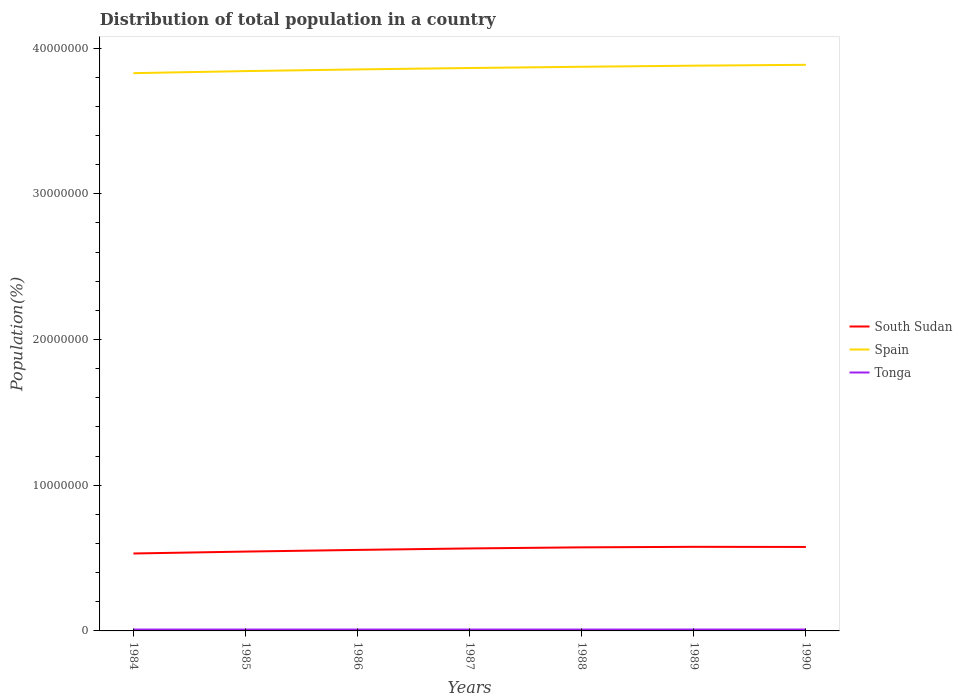Across all years, what is the maximum population of in Spain?
Your response must be concise. 3.83e+07. What is the total population of in South Sudan in the graph?
Offer a very short reply. -2.90e+05. What is the difference between the highest and the second highest population of in Spain?
Ensure brevity in your answer.  5.72e+05. How many lines are there?
Your response must be concise. 3. How many years are there in the graph?
Offer a very short reply. 7. Are the values on the major ticks of Y-axis written in scientific E-notation?
Offer a very short reply. No. How are the legend labels stacked?
Your answer should be very brief. Vertical. What is the title of the graph?
Give a very brief answer. Distribution of total population in a country. Does "Fiji" appear as one of the legend labels in the graph?
Provide a short and direct response. No. What is the label or title of the Y-axis?
Your response must be concise. Population(%). What is the Population(%) of South Sudan in 1984?
Your answer should be very brief. 5.31e+06. What is the Population(%) in Spain in 1984?
Provide a short and direct response. 3.83e+07. What is the Population(%) in Tonga in 1984?
Make the answer very short. 9.38e+04. What is the Population(%) in South Sudan in 1985?
Ensure brevity in your answer.  5.44e+06. What is the Population(%) of Spain in 1985?
Provide a succinct answer. 3.84e+07. What is the Population(%) in Tonga in 1985?
Provide a succinct answer. 9.40e+04. What is the Population(%) in South Sudan in 1986?
Provide a succinct answer. 5.56e+06. What is the Population(%) of Spain in 1986?
Ensure brevity in your answer.  3.85e+07. What is the Population(%) in Tonga in 1986?
Your answer should be compact. 9.41e+04. What is the Population(%) of South Sudan in 1987?
Offer a terse response. 5.66e+06. What is the Population(%) of Spain in 1987?
Your answer should be compact. 3.86e+07. What is the Population(%) of Tonga in 1987?
Offer a very short reply. 9.44e+04. What is the Population(%) of South Sudan in 1988?
Offer a very short reply. 5.74e+06. What is the Population(%) in Spain in 1988?
Your answer should be compact. 3.87e+07. What is the Population(%) in Tonga in 1988?
Make the answer very short. 9.47e+04. What is the Population(%) in South Sudan in 1989?
Offer a very short reply. 5.77e+06. What is the Population(%) of Spain in 1989?
Offer a very short reply. 3.88e+07. What is the Population(%) of Tonga in 1989?
Your response must be concise. 9.49e+04. What is the Population(%) in South Sudan in 1990?
Your response must be concise. 5.76e+06. What is the Population(%) in Spain in 1990?
Make the answer very short. 3.89e+07. What is the Population(%) in Tonga in 1990?
Ensure brevity in your answer.  9.52e+04. Across all years, what is the maximum Population(%) in South Sudan?
Ensure brevity in your answer.  5.77e+06. Across all years, what is the maximum Population(%) of Spain?
Offer a terse response. 3.89e+07. Across all years, what is the maximum Population(%) of Tonga?
Provide a short and direct response. 9.52e+04. Across all years, what is the minimum Population(%) in South Sudan?
Offer a very short reply. 5.31e+06. Across all years, what is the minimum Population(%) of Spain?
Keep it short and to the point. 3.83e+07. Across all years, what is the minimum Population(%) in Tonga?
Provide a succinct answer. 9.38e+04. What is the total Population(%) of South Sudan in the graph?
Offer a very short reply. 3.92e+07. What is the total Population(%) of Spain in the graph?
Provide a short and direct response. 2.70e+08. What is the total Population(%) in Tonga in the graph?
Offer a very short reply. 6.61e+05. What is the difference between the Population(%) in South Sudan in 1984 and that in 1985?
Your answer should be very brief. -1.31e+05. What is the difference between the Population(%) in Spain in 1984 and that in 1985?
Give a very brief answer. -1.40e+05. What is the difference between the Population(%) in Tonga in 1984 and that in 1985?
Your answer should be compact. -115. What is the difference between the Population(%) of South Sudan in 1984 and that in 1986?
Offer a very short reply. -2.45e+05. What is the difference between the Population(%) of Spain in 1984 and that in 1986?
Keep it short and to the point. -2.57e+05. What is the difference between the Population(%) of Tonga in 1984 and that in 1986?
Your answer should be very brief. -309. What is the difference between the Population(%) of South Sudan in 1984 and that in 1987?
Keep it short and to the point. -3.46e+05. What is the difference between the Population(%) of Spain in 1984 and that in 1987?
Offer a very short reply. -3.52e+05. What is the difference between the Population(%) of Tonga in 1984 and that in 1987?
Provide a short and direct response. -561. What is the difference between the Population(%) of South Sudan in 1984 and that in 1988?
Keep it short and to the point. -4.21e+05. What is the difference between the Population(%) in Spain in 1984 and that in 1988?
Provide a short and direct response. -4.37e+05. What is the difference between the Population(%) of Tonga in 1984 and that in 1988?
Your answer should be very brief. -842. What is the difference between the Population(%) of South Sudan in 1984 and that in 1989?
Provide a short and direct response. -4.57e+05. What is the difference between the Population(%) in Spain in 1984 and that in 1989?
Provide a short and direct response. -5.13e+05. What is the difference between the Population(%) in Tonga in 1984 and that in 1989?
Give a very brief answer. -1105. What is the difference between the Population(%) of South Sudan in 1984 and that in 1990?
Make the answer very short. -4.48e+05. What is the difference between the Population(%) in Spain in 1984 and that in 1990?
Your answer should be very brief. -5.72e+05. What is the difference between the Population(%) of Tonga in 1984 and that in 1990?
Offer a very short reply. -1314. What is the difference between the Population(%) of South Sudan in 1985 and that in 1986?
Keep it short and to the point. -1.15e+05. What is the difference between the Population(%) of Spain in 1985 and that in 1986?
Keep it short and to the point. -1.17e+05. What is the difference between the Population(%) of Tonga in 1985 and that in 1986?
Your answer should be compact. -194. What is the difference between the Population(%) in South Sudan in 1985 and that in 1987?
Your answer should be compact. -2.15e+05. What is the difference between the Population(%) in Spain in 1985 and that in 1987?
Ensure brevity in your answer.  -2.12e+05. What is the difference between the Population(%) in Tonga in 1985 and that in 1987?
Ensure brevity in your answer.  -446. What is the difference between the Population(%) in South Sudan in 1985 and that in 1988?
Keep it short and to the point. -2.90e+05. What is the difference between the Population(%) of Spain in 1985 and that in 1988?
Offer a very short reply. -2.97e+05. What is the difference between the Population(%) in Tonga in 1985 and that in 1988?
Your answer should be very brief. -727. What is the difference between the Population(%) of South Sudan in 1985 and that in 1989?
Keep it short and to the point. -3.26e+05. What is the difference between the Population(%) in Spain in 1985 and that in 1989?
Give a very brief answer. -3.73e+05. What is the difference between the Population(%) of Tonga in 1985 and that in 1989?
Offer a terse response. -990. What is the difference between the Population(%) of South Sudan in 1985 and that in 1990?
Your answer should be compact. -3.17e+05. What is the difference between the Population(%) in Spain in 1985 and that in 1990?
Provide a succinct answer. -4.32e+05. What is the difference between the Population(%) of Tonga in 1985 and that in 1990?
Keep it short and to the point. -1199. What is the difference between the Population(%) of South Sudan in 1986 and that in 1987?
Keep it short and to the point. -1.00e+05. What is the difference between the Population(%) in Spain in 1986 and that in 1987?
Provide a short and direct response. -9.52e+04. What is the difference between the Population(%) of Tonga in 1986 and that in 1987?
Provide a succinct answer. -252. What is the difference between the Population(%) of South Sudan in 1986 and that in 1988?
Your answer should be compact. -1.75e+05. What is the difference between the Population(%) of Spain in 1986 and that in 1988?
Offer a very short reply. -1.80e+05. What is the difference between the Population(%) in Tonga in 1986 and that in 1988?
Your answer should be very brief. -533. What is the difference between the Population(%) in South Sudan in 1986 and that in 1989?
Offer a terse response. -2.12e+05. What is the difference between the Population(%) in Spain in 1986 and that in 1989?
Make the answer very short. -2.56e+05. What is the difference between the Population(%) of Tonga in 1986 and that in 1989?
Your answer should be compact. -796. What is the difference between the Population(%) in South Sudan in 1986 and that in 1990?
Provide a short and direct response. -2.02e+05. What is the difference between the Population(%) of Spain in 1986 and that in 1990?
Make the answer very short. -3.15e+05. What is the difference between the Population(%) in Tonga in 1986 and that in 1990?
Your response must be concise. -1005. What is the difference between the Population(%) of South Sudan in 1987 and that in 1988?
Provide a short and direct response. -7.50e+04. What is the difference between the Population(%) of Spain in 1987 and that in 1988?
Your answer should be very brief. -8.50e+04. What is the difference between the Population(%) of Tonga in 1987 and that in 1988?
Provide a short and direct response. -281. What is the difference between the Population(%) in South Sudan in 1987 and that in 1989?
Offer a very short reply. -1.11e+05. What is the difference between the Population(%) in Spain in 1987 and that in 1989?
Ensure brevity in your answer.  -1.61e+05. What is the difference between the Population(%) of Tonga in 1987 and that in 1989?
Offer a terse response. -544. What is the difference between the Population(%) in South Sudan in 1987 and that in 1990?
Keep it short and to the point. -1.02e+05. What is the difference between the Population(%) of Spain in 1987 and that in 1990?
Provide a short and direct response. -2.20e+05. What is the difference between the Population(%) of Tonga in 1987 and that in 1990?
Ensure brevity in your answer.  -753. What is the difference between the Population(%) of South Sudan in 1988 and that in 1989?
Provide a short and direct response. -3.61e+04. What is the difference between the Population(%) in Spain in 1988 and that in 1989?
Offer a terse response. -7.56e+04. What is the difference between the Population(%) in Tonga in 1988 and that in 1989?
Offer a terse response. -263. What is the difference between the Population(%) in South Sudan in 1988 and that in 1990?
Your response must be concise. -2.70e+04. What is the difference between the Population(%) of Spain in 1988 and that in 1990?
Your answer should be compact. -1.35e+05. What is the difference between the Population(%) in Tonga in 1988 and that in 1990?
Provide a short and direct response. -472. What is the difference between the Population(%) of South Sudan in 1989 and that in 1990?
Offer a terse response. 9115. What is the difference between the Population(%) of Spain in 1989 and that in 1990?
Make the answer very short. -5.90e+04. What is the difference between the Population(%) in Tonga in 1989 and that in 1990?
Your answer should be very brief. -209. What is the difference between the Population(%) of South Sudan in 1984 and the Population(%) of Spain in 1985?
Provide a succinct answer. -3.31e+07. What is the difference between the Population(%) in South Sudan in 1984 and the Population(%) in Tonga in 1985?
Your answer should be very brief. 5.22e+06. What is the difference between the Population(%) in Spain in 1984 and the Population(%) in Tonga in 1985?
Provide a succinct answer. 3.82e+07. What is the difference between the Population(%) of South Sudan in 1984 and the Population(%) of Spain in 1986?
Your response must be concise. -3.32e+07. What is the difference between the Population(%) of South Sudan in 1984 and the Population(%) of Tonga in 1986?
Provide a short and direct response. 5.22e+06. What is the difference between the Population(%) of Spain in 1984 and the Population(%) of Tonga in 1986?
Provide a succinct answer. 3.82e+07. What is the difference between the Population(%) in South Sudan in 1984 and the Population(%) in Spain in 1987?
Your answer should be very brief. -3.33e+07. What is the difference between the Population(%) of South Sudan in 1984 and the Population(%) of Tonga in 1987?
Provide a short and direct response. 5.22e+06. What is the difference between the Population(%) in Spain in 1984 and the Population(%) in Tonga in 1987?
Your answer should be very brief. 3.82e+07. What is the difference between the Population(%) in South Sudan in 1984 and the Population(%) in Spain in 1988?
Give a very brief answer. -3.34e+07. What is the difference between the Population(%) of South Sudan in 1984 and the Population(%) of Tonga in 1988?
Your answer should be compact. 5.22e+06. What is the difference between the Population(%) of Spain in 1984 and the Population(%) of Tonga in 1988?
Give a very brief answer. 3.82e+07. What is the difference between the Population(%) in South Sudan in 1984 and the Population(%) in Spain in 1989?
Offer a very short reply. -3.35e+07. What is the difference between the Population(%) of South Sudan in 1984 and the Population(%) of Tonga in 1989?
Keep it short and to the point. 5.22e+06. What is the difference between the Population(%) of Spain in 1984 and the Population(%) of Tonga in 1989?
Give a very brief answer. 3.82e+07. What is the difference between the Population(%) of South Sudan in 1984 and the Population(%) of Spain in 1990?
Your answer should be very brief. -3.35e+07. What is the difference between the Population(%) of South Sudan in 1984 and the Population(%) of Tonga in 1990?
Your response must be concise. 5.22e+06. What is the difference between the Population(%) of Spain in 1984 and the Population(%) of Tonga in 1990?
Your response must be concise. 3.82e+07. What is the difference between the Population(%) of South Sudan in 1985 and the Population(%) of Spain in 1986?
Make the answer very short. -3.31e+07. What is the difference between the Population(%) of South Sudan in 1985 and the Population(%) of Tonga in 1986?
Your answer should be very brief. 5.35e+06. What is the difference between the Population(%) in Spain in 1985 and the Population(%) in Tonga in 1986?
Ensure brevity in your answer.  3.83e+07. What is the difference between the Population(%) of South Sudan in 1985 and the Population(%) of Spain in 1987?
Make the answer very short. -3.32e+07. What is the difference between the Population(%) of South Sudan in 1985 and the Population(%) of Tonga in 1987?
Offer a very short reply. 5.35e+06. What is the difference between the Population(%) of Spain in 1985 and the Population(%) of Tonga in 1987?
Ensure brevity in your answer.  3.83e+07. What is the difference between the Population(%) of South Sudan in 1985 and the Population(%) of Spain in 1988?
Offer a terse response. -3.33e+07. What is the difference between the Population(%) in South Sudan in 1985 and the Population(%) in Tonga in 1988?
Keep it short and to the point. 5.35e+06. What is the difference between the Population(%) of Spain in 1985 and the Population(%) of Tonga in 1988?
Your response must be concise. 3.83e+07. What is the difference between the Population(%) of South Sudan in 1985 and the Population(%) of Spain in 1989?
Ensure brevity in your answer.  -3.33e+07. What is the difference between the Population(%) in South Sudan in 1985 and the Population(%) in Tonga in 1989?
Your answer should be very brief. 5.35e+06. What is the difference between the Population(%) in Spain in 1985 and the Population(%) in Tonga in 1989?
Give a very brief answer. 3.83e+07. What is the difference between the Population(%) of South Sudan in 1985 and the Population(%) of Spain in 1990?
Offer a terse response. -3.34e+07. What is the difference between the Population(%) in South Sudan in 1985 and the Population(%) in Tonga in 1990?
Offer a terse response. 5.35e+06. What is the difference between the Population(%) of Spain in 1985 and the Population(%) of Tonga in 1990?
Give a very brief answer. 3.83e+07. What is the difference between the Population(%) of South Sudan in 1986 and the Population(%) of Spain in 1987?
Provide a succinct answer. -3.31e+07. What is the difference between the Population(%) in South Sudan in 1986 and the Population(%) in Tonga in 1987?
Provide a short and direct response. 5.47e+06. What is the difference between the Population(%) of Spain in 1986 and the Population(%) of Tonga in 1987?
Ensure brevity in your answer.  3.84e+07. What is the difference between the Population(%) of South Sudan in 1986 and the Population(%) of Spain in 1988?
Your answer should be compact. -3.32e+07. What is the difference between the Population(%) of South Sudan in 1986 and the Population(%) of Tonga in 1988?
Give a very brief answer. 5.47e+06. What is the difference between the Population(%) of Spain in 1986 and the Population(%) of Tonga in 1988?
Give a very brief answer. 3.84e+07. What is the difference between the Population(%) in South Sudan in 1986 and the Population(%) in Spain in 1989?
Your response must be concise. -3.32e+07. What is the difference between the Population(%) of South Sudan in 1986 and the Population(%) of Tonga in 1989?
Give a very brief answer. 5.46e+06. What is the difference between the Population(%) in Spain in 1986 and the Population(%) in Tonga in 1989?
Offer a terse response. 3.84e+07. What is the difference between the Population(%) in South Sudan in 1986 and the Population(%) in Spain in 1990?
Offer a terse response. -3.33e+07. What is the difference between the Population(%) in South Sudan in 1986 and the Population(%) in Tonga in 1990?
Your answer should be very brief. 5.46e+06. What is the difference between the Population(%) in Spain in 1986 and the Population(%) in Tonga in 1990?
Make the answer very short. 3.84e+07. What is the difference between the Population(%) of South Sudan in 1987 and the Population(%) of Spain in 1988?
Provide a short and direct response. -3.31e+07. What is the difference between the Population(%) of South Sudan in 1987 and the Population(%) of Tonga in 1988?
Offer a terse response. 5.57e+06. What is the difference between the Population(%) of Spain in 1987 and the Population(%) of Tonga in 1988?
Provide a succinct answer. 3.85e+07. What is the difference between the Population(%) of South Sudan in 1987 and the Population(%) of Spain in 1989?
Offer a terse response. -3.31e+07. What is the difference between the Population(%) in South Sudan in 1987 and the Population(%) in Tonga in 1989?
Your response must be concise. 5.57e+06. What is the difference between the Population(%) in Spain in 1987 and the Population(%) in Tonga in 1989?
Keep it short and to the point. 3.85e+07. What is the difference between the Population(%) of South Sudan in 1987 and the Population(%) of Spain in 1990?
Your response must be concise. -3.32e+07. What is the difference between the Population(%) of South Sudan in 1987 and the Population(%) of Tonga in 1990?
Offer a terse response. 5.57e+06. What is the difference between the Population(%) in Spain in 1987 and the Population(%) in Tonga in 1990?
Offer a very short reply. 3.85e+07. What is the difference between the Population(%) of South Sudan in 1988 and the Population(%) of Spain in 1989?
Offer a very short reply. -3.31e+07. What is the difference between the Population(%) of South Sudan in 1988 and the Population(%) of Tonga in 1989?
Your answer should be compact. 5.64e+06. What is the difference between the Population(%) in Spain in 1988 and the Population(%) in Tonga in 1989?
Make the answer very short. 3.86e+07. What is the difference between the Population(%) of South Sudan in 1988 and the Population(%) of Spain in 1990?
Keep it short and to the point. -3.31e+07. What is the difference between the Population(%) of South Sudan in 1988 and the Population(%) of Tonga in 1990?
Provide a short and direct response. 5.64e+06. What is the difference between the Population(%) of Spain in 1988 and the Population(%) of Tonga in 1990?
Ensure brevity in your answer.  3.86e+07. What is the difference between the Population(%) of South Sudan in 1989 and the Population(%) of Spain in 1990?
Offer a very short reply. -3.31e+07. What is the difference between the Population(%) in South Sudan in 1989 and the Population(%) in Tonga in 1990?
Offer a very short reply. 5.68e+06. What is the difference between the Population(%) of Spain in 1989 and the Population(%) of Tonga in 1990?
Your response must be concise. 3.87e+07. What is the average Population(%) of South Sudan per year?
Keep it short and to the point. 5.61e+06. What is the average Population(%) in Spain per year?
Provide a short and direct response. 3.86e+07. What is the average Population(%) in Tonga per year?
Ensure brevity in your answer.  9.44e+04. In the year 1984, what is the difference between the Population(%) of South Sudan and Population(%) of Spain?
Your answer should be compact. -3.30e+07. In the year 1984, what is the difference between the Population(%) in South Sudan and Population(%) in Tonga?
Make the answer very short. 5.22e+06. In the year 1984, what is the difference between the Population(%) in Spain and Population(%) in Tonga?
Provide a short and direct response. 3.82e+07. In the year 1985, what is the difference between the Population(%) in South Sudan and Population(%) in Spain?
Offer a very short reply. -3.30e+07. In the year 1985, what is the difference between the Population(%) of South Sudan and Population(%) of Tonga?
Provide a succinct answer. 5.35e+06. In the year 1985, what is the difference between the Population(%) in Spain and Population(%) in Tonga?
Provide a short and direct response. 3.83e+07. In the year 1986, what is the difference between the Population(%) in South Sudan and Population(%) in Spain?
Keep it short and to the point. -3.30e+07. In the year 1986, what is the difference between the Population(%) of South Sudan and Population(%) of Tonga?
Provide a succinct answer. 5.47e+06. In the year 1986, what is the difference between the Population(%) of Spain and Population(%) of Tonga?
Offer a very short reply. 3.84e+07. In the year 1987, what is the difference between the Population(%) of South Sudan and Population(%) of Spain?
Your response must be concise. -3.30e+07. In the year 1987, what is the difference between the Population(%) in South Sudan and Population(%) in Tonga?
Your response must be concise. 5.57e+06. In the year 1987, what is the difference between the Population(%) of Spain and Population(%) of Tonga?
Make the answer very short. 3.85e+07. In the year 1988, what is the difference between the Population(%) of South Sudan and Population(%) of Spain?
Your answer should be very brief. -3.30e+07. In the year 1988, what is the difference between the Population(%) in South Sudan and Population(%) in Tonga?
Provide a short and direct response. 5.64e+06. In the year 1988, what is the difference between the Population(%) in Spain and Population(%) in Tonga?
Offer a very short reply. 3.86e+07. In the year 1989, what is the difference between the Population(%) in South Sudan and Population(%) in Spain?
Provide a succinct answer. -3.30e+07. In the year 1989, what is the difference between the Population(%) of South Sudan and Population(%) of Tonga?
Offer a very short reply. 5.68e+06. In the year 1989, what is the difference between the Population(%) in Spain and Population(%) in Tonga?
Your response must be concise. 3.87e+07. In the year 1990, what is the difference between the Population(%) of South Sudan and Population(%) of Spain?
Give a very brief answer. -3.31e+07. In the year 1990, what is the difference between the Population(%) in South Sudan and Population(%) in Tonga?
Provide a succinct answer. 5.67e+06. In the year 1990, what is the difference between the Population(%) in Spain and Population(%) in Tonga?
Provide a succinct answer. 3.88e+07. What is the ratio of the Population(%) of Spain in 1984 to that in 1985?
Your answer should be very brief. 1. What is the ratio of the Population(%) in Tonga in 1984 to that in 1985?
Your answer should be very brief. 1. What is the ratio of the Population(%) in South Sudan in 1984 to that in 1986?
Provide a short and direct response. 0.96. What is the ratio of the Population(%) in Spain in 1984 to that in 1986?
Offer a terse response. 0.99. What is the ratio of the Population(%) of Tonga in 1984 to that in 1986?
Offer a terse response. 1. What is the ratio of the Population(%) in South Sudan in 1984 to that in 1987?
Offer a very short reply. 0.94. What is the ratio of the Population(%) of Spain in 1984 to that in 1987?
Provide a succinct answer. 0.99. What is the ratio of the Population(%) in Tonga in 1984 to that in 1987?
Offer a very short reply. 0.99. What is the ratio of the Population(%) in South Sudan in 1984 to that in 1988?
Provide a short and direct response. 0.93. What is the ratio of the Population(%) in Spain in 1984 to that in 1988?
Make the answer very short. 0.99. What is the ratio of the Population(%) of South Sudan in 1984 to that in 1989?
Ensure brevity in your answer.  0.92. What is the ratio of the Population(%) of Spain in 1984 to that in 1989?
Offer a very short reply. 0.99. What is the ratio of the Population(%) in Tonga in 1984 to that in 1989?
Provide a short and direct response. 0.99. What is the ratio of the Population(%) of South Sudan in 1984 to that in 1990?
Your answer should be compact. 0.92. What is the ratio of the Population(%) in Spain in 1984 to that in 1990?
Your response must be concise. 0.99. What is the ratio of the Population(%) of Tonga in 1984 to that in 1990?
Make the answer very short. 0.99. What is the ratio of the Population(%) in South Sudan in 1985 to that in 1986?
Give a very brief answer. 0.98. What is the ratio of the Population(%) of Tonga in 1985 to that in 1986?
Provide a short and direct response. 1. What is the ratio of the Population(%) in South Sudan in 1985 to that in 1987?
Offer a terse response. 0.96. What is the ratio of the Population(%) in Spain in 1985 to that in 1987?
Your response must be concise. 0.99. What is the ratio of the Population(%) of Tonga in 1985 to that in 1987?
Ensure brevity in your answer.  1. What is the ratio of the Population(%) in South Sudan in 1985 to that in 1988?
Offer a very short reply. 0.95. What is the ratio of the Population(%) in Spain in 1985 to that in 1988?
Your response must be concise. 0.99. What is the ratio of the Population(%) of South Sudan in 1985 to that in 1989?
Provide a succinct answer. 0.94. What is the ratio of the Population(%) of Spain in 1985 to that in 1989?
Keep it short and to the point. 0.99. What is the ratio of the Population(%) in Tonga in 1985 to that in 1989?
Provide a succinct answer. 0.99. What is the ratio of the Population(%) of South Sudan in 1985 to that in 1990?
Provide a short and direct response. 0.94. What is the ratio of the Population(%) in Spain in 1985 to that in 1990?
Provide a short and direct response. 0.99. What is the ratio of the Population(%) of Tonga in 1985 to that in 1990?
Give a very brief answer. 0.99. What is the ratio of the Population(%) of South Sudan in 1986 to that in 1987?
Your response must be concise. 0.98. What is the ratio of the Population(%) in Spain in 1986 to that in 1987?
Keep it short and to the point. 1. What is the ratio of the Population(%) of South Sudan in 1986 to that in 1988?
Provide a short and direct response. 0.97. What is the ratio of the Population(%) of South Sudan in 1986 to that in 1989?
Offer a very short reply. 0.96. What is the ratio of the Population(%) in South Sudan in 1986 to that in 1990?
Your answer should be very brief. 0.96. What is the ratio of the Population(%) in Spain in 1986 to that in 1990?
Offer a very short reply. 0.99. What is the ratio of the Population(%) in South Sudan in 1987 to that in 1988?
Your response must be concise. 0.99. What is the ratio of the Population(%) of South Sudan in 1987 to that in 1989?
Give a very brief answer. 0.98. What is the ratio of the Population(%) of South Sudan in 1987 to that in 1990?
Keep it short and to the point. 0.98. What is the ratio of the Population(%) of Spain in 1987 to that in 1990?
Your answer should be very brief. 0.99. What is the ratio of the Population(%) of South Sudan in 1988 to that in 1989?
Offer a terse response. 0.99. What is the ratio of the Population(%) of Spain in 1988 to that in 1989?
Provide a short and direct response. 1. What is the ratio of the Population(%) of Tonga in 1988 to that in 1989?
Your answer should be compact. 1. What is the ratio of the Population(%) in South Sudan in 1988 to that in 1990?
Ensure brevity in your answer.  1. What is the ratio of the Population(%) of Spain in 1988 to that in 1990?
Provide a succinct answer. 1. What is the ratio of the Population(%) in Spain in 1989 to that in 1990?
Keep it short and to the point. 1. What is the ratio of the Population(%) in Tonga in 1989 to that in 1990?
Make the answer very short. 1. What is the difference between the highest and the second highest Population(%) of South Sudan?
Offer a very short reply. 9115. What is the difference between the highest and the second highest Population(%) in Spain?
Provide a short and direct response. 5.90e+04. What is the difference between the highest and the second highest Population(%) in Tonga?
Provide a succinct answer. 209. What is the difference between the highest and the lowest Population(%) of South Sudan?
Provide a short and direct response. 4.57e+05. What is the difference between the highest and the lowest Population(%) of Spain?
Provide a succinct answer. 5.72e+05. What is the difference between the highest and the lowest Population(%) of Tonga?
Your answer should be compact. 1314. 